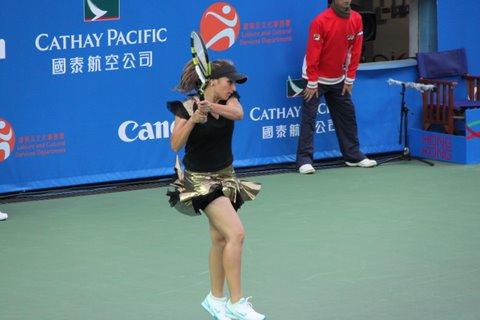What color is the visor on the woman's head?
Short answer required. Black. Is the skirt of the woman holding the racket too short?
Short answer required. No. What is being advertised on the chair?
Quick response, please. Hong kong. What car brand has a sponsor banner on the wall?
Concise answer only. None. What color is her dress?
Short answer required. Black. What car manufacturer sponsors this tournament?
Concise answer only. Canon. In what country is this event?
Write a very short answer. China. What is the job for the person wearing red?
Quick response, please. Referee. Which country is this probably in?
Concise answer only. China. What game is being played?
Answer briefly. Tennis. 